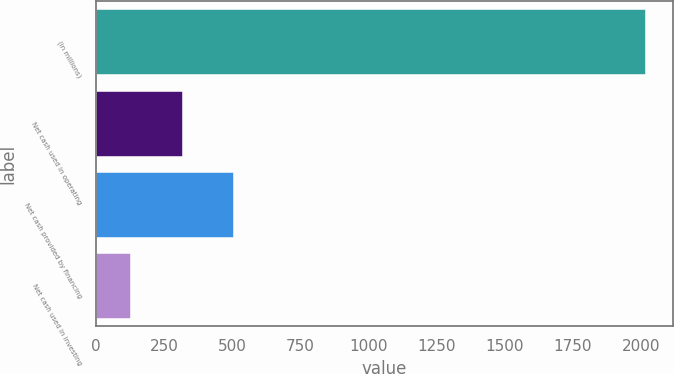Convert chart. <chart><loc_0><loc_0><loc_500><loc_500><bar_chart><fcel>(in millions)<fcel>Net cash used in operating<fcel>Net cash provided by financing<fcel>Net cash used in investing<nl><fcel>2016<fcel>314.1<fcel>503.2<fcel>125<nl></chart> 